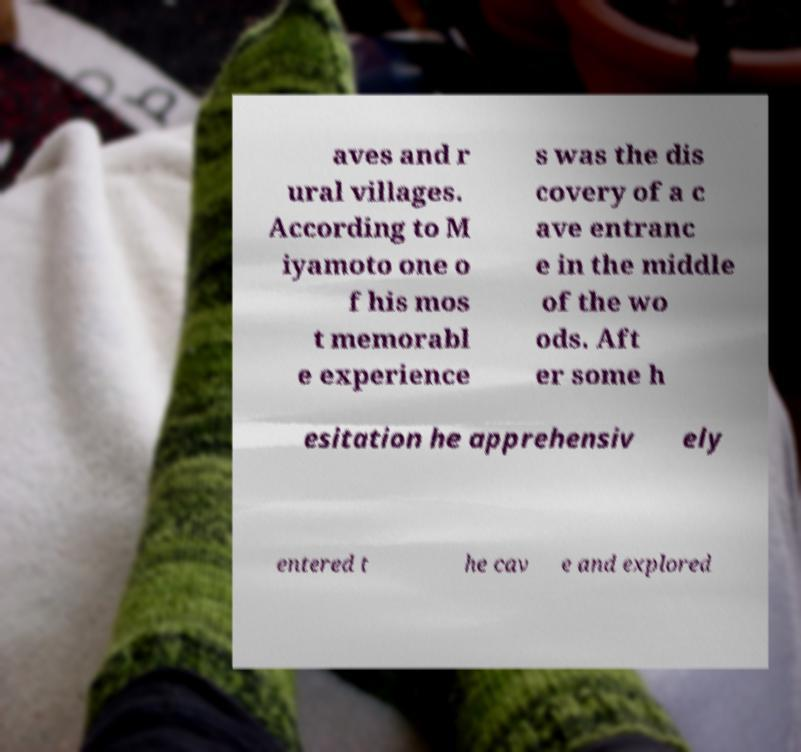Please read and relay the text visible in this image. What does it say? aves and r ural villages. According to M iyamoto one o f his mos t memorabl e experience s was the dis covery of a c ave entranc e in the middle of the wo ods. Aft er some h esitation he apprehensiv ely entered t he cav e and explored 